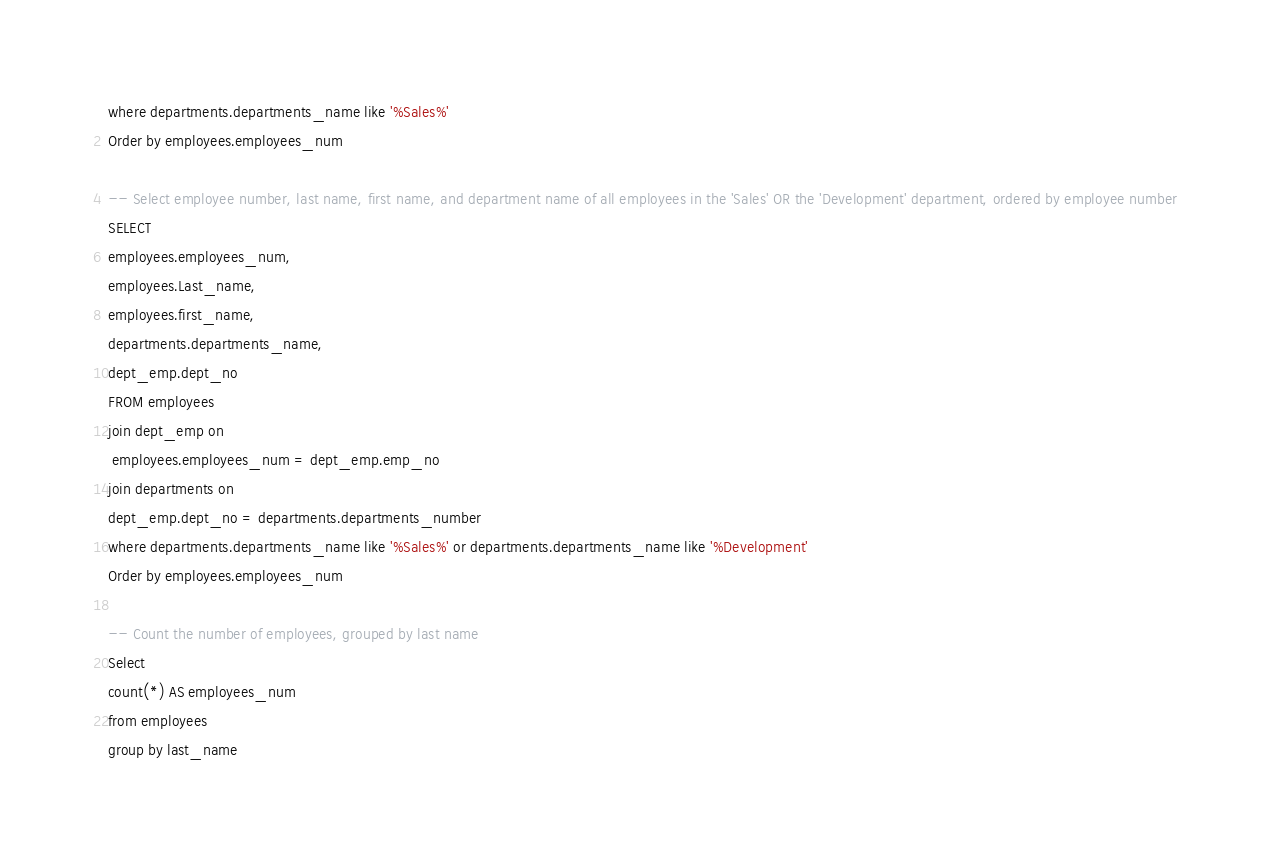<code> <loc_0><loc_0><loc_500><loc_500><_SQL_>where departments.departments_name like '%Sales%'
Order by employees.employees_num

-- Select employee number, last name, first name, and department name of all employees in the 'Sales' OR the 'Development' department, ordered by employee number
SELECT 
employees.employees_num,
employees.Last_name,
employees.first_name,
departments.departments_name,
dept_emp.dept_no
FROM employees
join dept_emp on 
 employees.employees_num = dept_emp.emp_no
join departments on 
dept_emp.dept_no = departments.departments_number
where departments.departments_name like '%Sales%' or departments.departments_name like '%Development'
Order by employees.employees_num

-- Count the number of employees, grouped by last name
Select 
count(*) AS employees_num
from employees
group by last_name</code> 